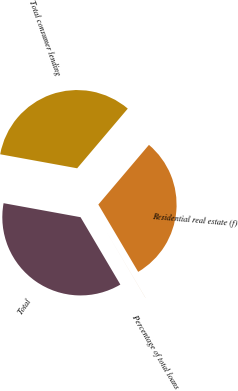<chart> <loc_0><loc_0><loc_500><loc_500><pie_chart><fcel>Residential real estate (f)<fcel>Total consumer lending<fcel>Total<fcel>Percentage of total loans<nl><fcel>30.3%<fcel>33.33%<fcel>36.36%<fcel>0.01%<nl></chart> 